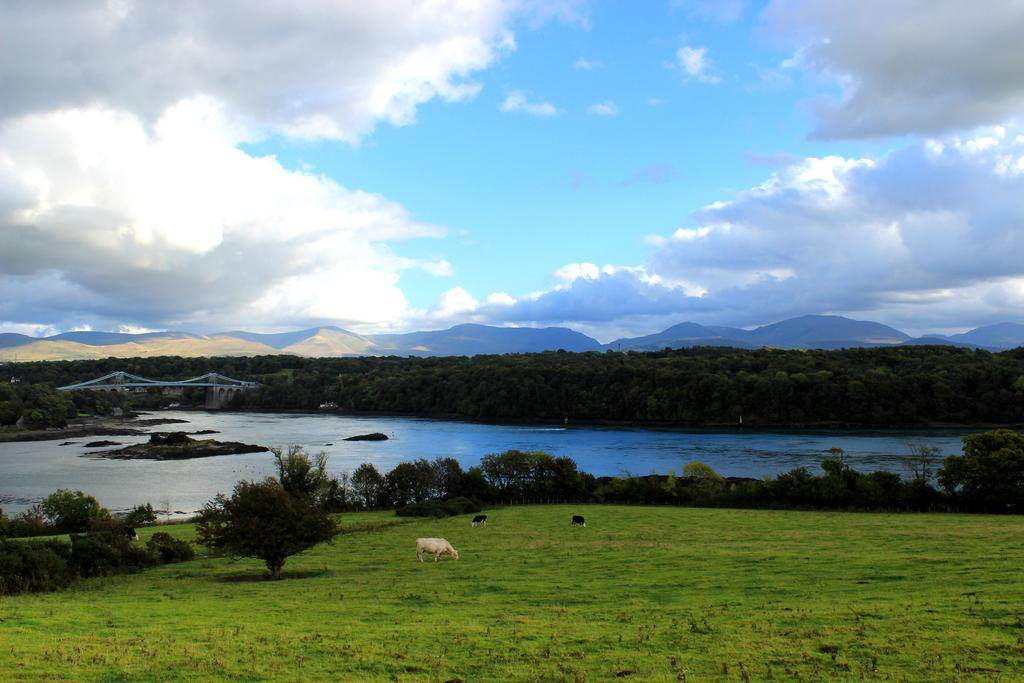What is the primary element visible in the image? There is water in the image. What type of vegetation can be seen in the image? There are trees in the image. What are the animals in the image doing? The animals are standing on the ground in the image. What can be seen in the distance in the image? There are mountains visible in the background of the image. What is visible above the mountains in the image? The sky is visible in the background of the image. What type of terrain is present in the image? There is grass in the image. What is the income of the animals in the image? There is no information about the income of the animals in the image, as income is not a characteristic that can be determined from the image. 